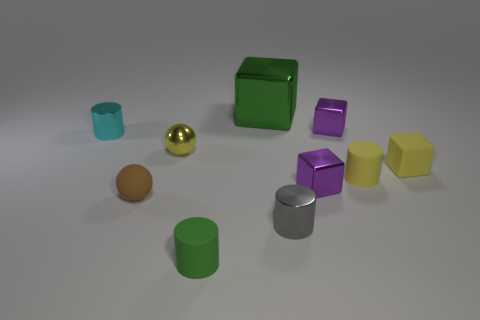Subtract all yellow blocks. How many blocks are left? 3 Subtract all brown balls. How many balls are left? 1 Subtract 3 blocks. How many blocks are left? 1 Add 8 small gray cylinders. How many small gray cylinders exist? 9 Subtract 0 purple cylinders. How many objects are left? 10 Subtract all cubes. How many objects are left? 6 Subtract all brown cylinders. Subtract all brown blocks. How many cylinders are left? 4 Subtract all blue balls. How many blue cylinders are left? 0 Subtract all rubber objects. Subtract all small brown things. How many objects are left? 5 Add 5 tiny brown matte things. How many tiny brown matte things are left? 6 